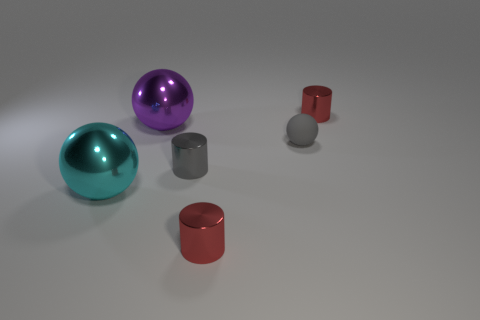The metallic object that is the same size as the purple metallic ball is what color?
Provide a succinct answer. Cyan. What number of things are either tiny red metallic cylinders behind the gray cylinder or big things?
Your answer should be very brief. 3. How big is the ball that is both to the left of the gray cylinder and behind the large cyan object?
Ensure brevity in your answer.  Large. How many other things are there of the same size as the cyan shiny sphere?
Offer a terse response. 1. The metallic cylinder that is in front of the tiny shiny cylinder that is on the left side of the red cylinder that is to the left of the matte ball is what color?
Keep it short and to the point. Red. There is a metallic object that is behind the small gray metallic cylinder and to the right of the large purple shiny thing; what shape is it?
Your answer should be very brief. Cylinder. What number of other things are the same shape as the big cyan metallic object?
Offer a terse response. 2. The tiny red thing on the right side of the small thing in front of the metal sphere that is in front of the purple shiny ball is what shape?
Offer a terse response. Cylinder. What number of objects are tiny objects or tiny cylinders to the right of the tiny gray ball?
Keep it short and to the point. 4. Do the tiny metal thing that is behind the gray matte object and the tiny thing that is in front of the large cyan shiny ball have the same shape?
Your answer should be compact. Yes. 